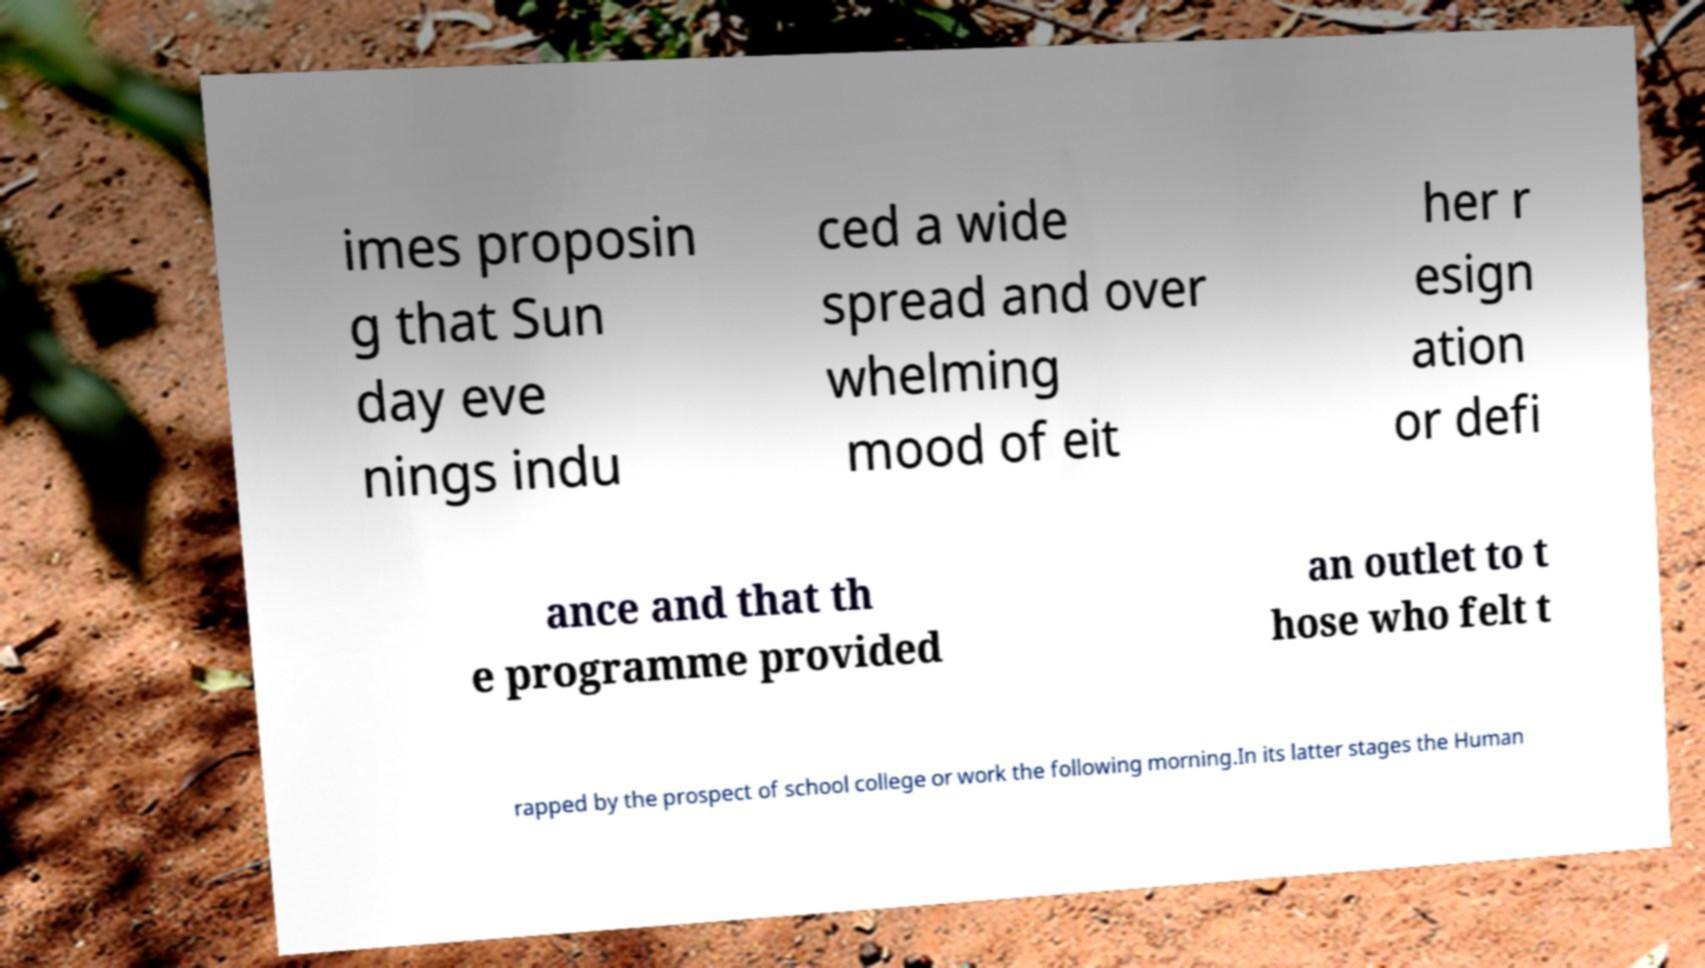Can you read and provide the text displayed in the image?This photo seems to have some interesting text. Can you extract and type it out for me? imes proposin g that Sun day eve nings indu ced a wide spread and over whelming mood of eit her r esign ation or defi ance and that th e programme provided an outlet to t hose who felt t rapped by the prospect of school college or work the following morning.In its latter stages the Human 